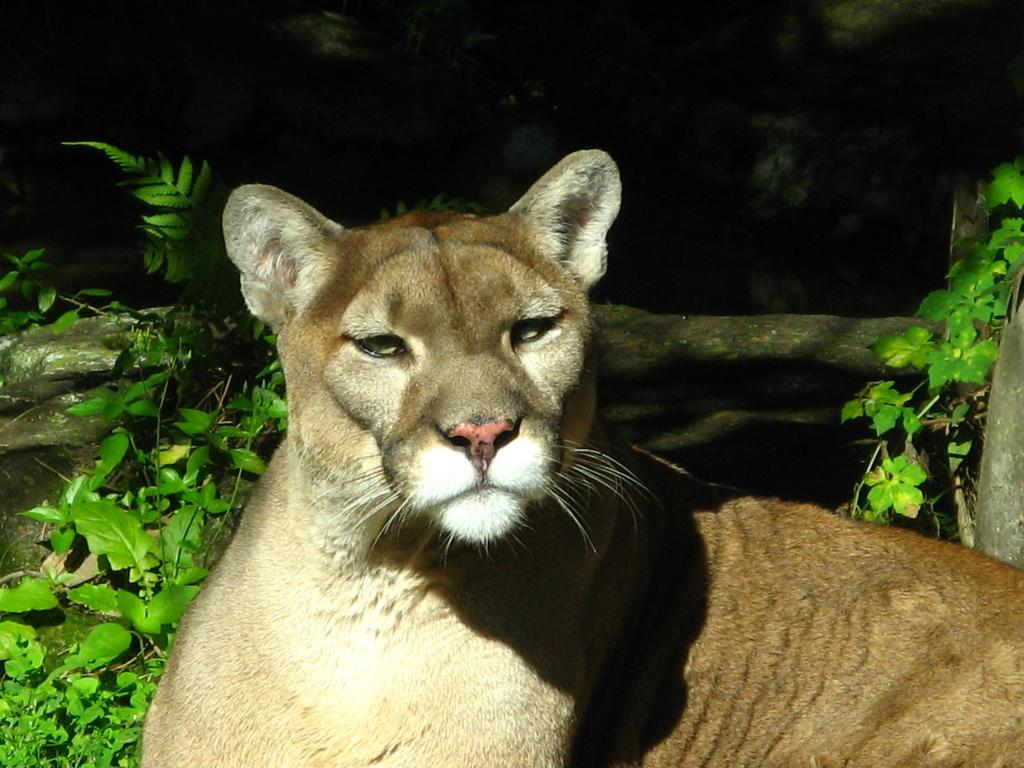What type of animal is in the image? There is a lioness in the image. What is the position of the lioness in the image? The lioness is sitting on the ground. What type of vegetation is visible in the image? There are plants visible in the image. What is the father of the lioness doing in the image? There is no father of the lioness present in the image. How many cows can be seen grazing in the background of the image? There are no cows visible in the image. What nation's flag is being waved in the image? There is no flag or indication of a specific nation in the image. 